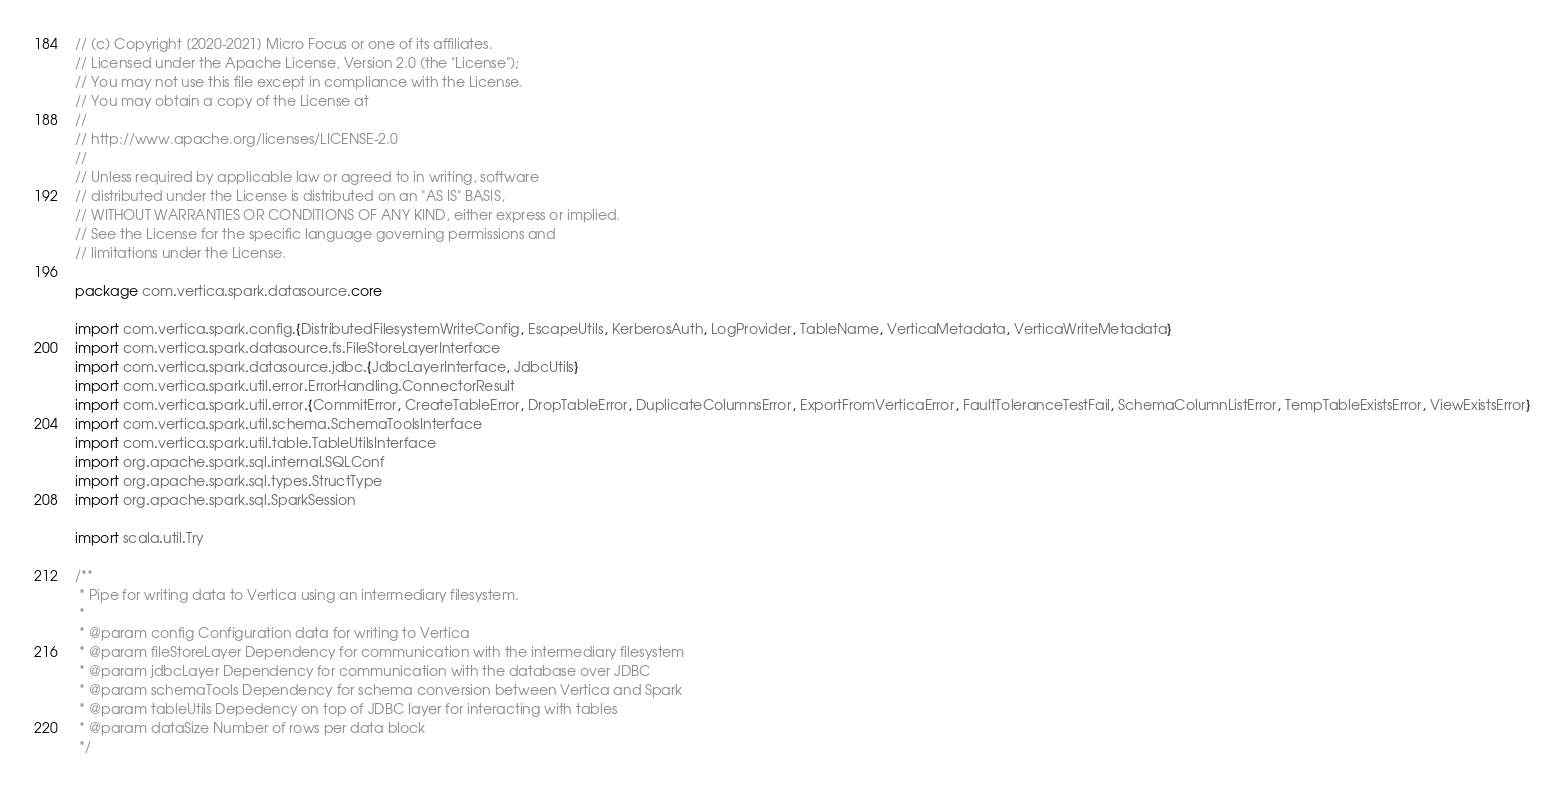Convert code to text. <code><loc_0><loc_0><loc_500><loc_500><_Scala_>// (c) Copyright [2020-2021] Micro Focus or one of its affiliates.
// Licensed under the Apache License, Version 2.0 (the "License");
// You may not use this file except in compliance with the License.
// You may obtain a copy of the License at
//
// http://www.apache.org/licenses/LICENSE-2.0
//
// Unless required by applicable law or agreed to in writing, software
// distributed under the License is distributed on an "AS IS" BASIS,
// WITHOUT WARRANTIES OR CONDITIONS OF ANY KIND, either express or implied.
// See the License for the specific language governing permissions and
// limitations under the License.

package com.vertica.spark.datasource.core

import com.vertica.spark.config.{DistributedFilesystemWriteConfig, EscapeUtils, KerberosAuth, LogProvider, TableName, VerticaMetadata, VerticaWriteMetadata}
import com.vertica.spark.datasource.fs.FileStoreLayerInterface
import com.vertica.spark.datasource.jdbc.{JdbcLayerInterface, JdbcUtils}
import com.vertica.spark.util.error.ErrorHandling.ConnectorResult
import com.vertica.spark.util.error.{CommitError, CreateTableError, DropTableError, DuplicateColumnsError, ExportFromVerticaError, FaultToleranceTestFail, SchemaColumnListError, TempTableExistsError, ViewExistsError}
import com.vertica.spark.util.schema.SchemaToolsInterface
import com.vertica.spark.util.table.TableUtilsInterface
import org.apache.spark.sql.internal.SQLConf
import org.apache.spark.sql.types.StructType
import org.apache.spark.sql.SparkSession

import scala.util.Try

/**
 * Pipe for writing data to Vertica using an intermediary filesystem.
 *
 * @param config Configuration data for writing to Vertica
 * @param fileStoreLayer Dependency for communication with the intermediary filesystem
 * @param jdbcLayer Dependency for communication with the database over JDBC
 * @param schemaTools Dependency for schema conversion between Vertica and Spark
 * @param tableUtils Depedency on top of JDBC layer for interacting with tables
 * @param dataSize Number of rows per data block
 */</code> 